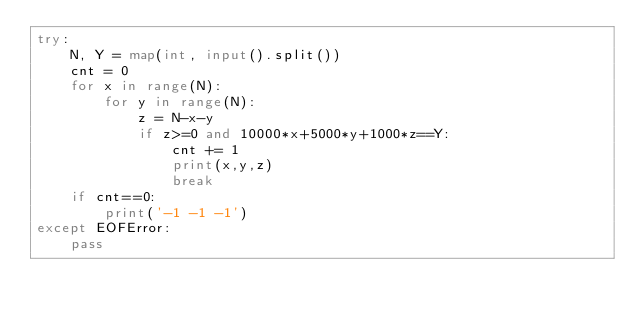<code> <loc_0><loc_0><loc_500><loc_500><_Python_>try:
    N, Y = map(int, input().split())
    cnt = 0
    for x in range(N):
        for y in range(N):
            z = N-x-y
            if z>=0 and 10000*x+5000*y+1000*z==Y:
                cnt += 1
                print(x,y,z)
                break
    if cnt==0:
        print('-1 -1 -1')
except EOFError:
    pass</code> 